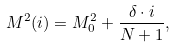Convert formula to latex. <formula><loc_0><loc_0><loc_500><loc_500>M ^ { 2 } ( i ) = M ^ { 2 } _ { 0 } + \frac { \delta \cdot i } { N + 1 } ,</formula> 